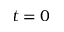<formula> <loc_0><loc_0><loc_500><loc_500>t = 0</formula> 